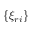Convert formula to latex. <formula><loc_0><loc_0><loc_500><loc_500>\{ \xi _ { r i } \}</formula> 